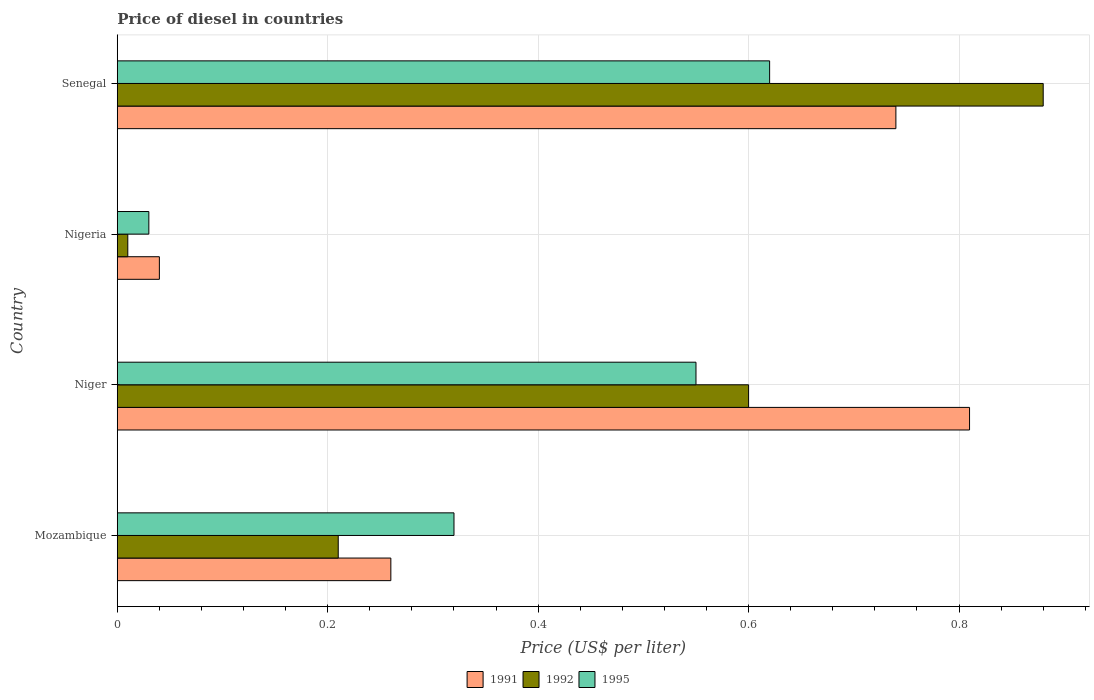What is the label of the 4th group of bars from the top?
Give a very brief answer. Mozambique. What is the price of diesel in 1991 in Nigeria?
Your answer should be compact. 0.04. Across all countries, what is the maximum price of diesel in 1991?
Offer a terse response. 0.81. Across all countries, what is the minimum price of diesel in 1991?
Ensure brevity in your answer.  0.04. In which country was the price of diesel in 1995 maximum?
Your answer should be very brief. Senegal. In which country was the price of diesel in 1995 minimum?
Ensure brevity in your answer.  Nigeria. What is the total price of diesel in 1991 in the graph?
Offer a terse response. 1.85. What is the difference between the price of diesel in 1991 in Niger and that in Senegal?
Ensure brevity in your answer.  0.07. What is the difference between the price of diesel in 1992 in Niger and the price of diesel in 1995 in Nigeria?
Offer a terse response. 0.57. What is the average price of diesel in 1991 per country?
Provide a short and direct response. 0.46. What is the difference between the price of diesel in 1991 and price of diesel in 1992 in Niger?
Give a very brief answer. 0.21. What is the ratio of the price of diesel in 1992 in Mozambique to that in Nigeria?
Make the answer very short. 21. Is the price of diesel in 1995 in Niger less than that in Nigeria?
Ensure brevity in your answer.  No. What is the difference between the highest and the second highest price of diesel in 1992?
Offer a terse response. 0.28. What is the difference between the highest and the lowest price of diesel in 1992?
Keep it short and to the point. 0.87. In how many countries, is the price of diesel in 1991 greater than the average price of diesel in 1991 taken over all countries?
Offer a terse response. 2. Is the sum of the price of diesel in 1992 in Mozambique and Senegal greater than the maximum price of diesel in 1991 across all countries?
Ensure brevity in your answer.  Yes. What does the 3rd bar from the bottom in Mozambique represents?
Give a very brief answer. 1995. Is it the case that in every country, the sum of the price of diesel in 1992 and price of diesel in 1991 is greater than the price of diesel in 1995?
Provide a short and direct response. Yes. How many bars are there?
Make the answer very short. 12. Are all the bars in the graph horizontal?
Keep it short and to the point. Yes. How many countries are there in the graph?
Give a very brief answer. 4. What is the difference between two consecutive major ticks on the X-axis?
Your answer should be compact. 0.2. Are the values on the major ticks of X-axis written in scientific E-notation?
Offer a very short reply. No. Does the graph contain grids?
Your answer should be very brief. Yes. How many legend labels are there?
Offer a terse response. 3. What is the title of the graph?
Offer a very short reply. Price of diesel in countries. Does "2006" appear as one of the legend labels in the graph?
Provide a short and direct response. No. What is the label or title of the X-axis?
Offer a terse response. Price (US$ per liter). What is the Price (US$ per liter) in 1991 in Mozambique?
Ensure brevity in your answer.  0.26. What is the Price (US$ per liter) of 1992 in Mozambique?
Give a very brief answer. 0.21. What is the Price (US$ per liter) in 1995 in Mozambique?
Ensure brevity in your answer.  0.32. What is the Price (US$ per liter) of 1991 in Niger?
Make the answer very short. 0.81. What is the Price (US$ per liter) of 1992 in Niger?
Your response must be concise. 0.6. What is the Price (US$ per liter) of 1995 in Niger?
Make the answer very short. 0.55. What is the Price (US$ per liter) of 1992 in Nigeria?
Give a very brief answer. 0.01. What is the Price (US$ per liter) in 1995 in Nigeria?
Give a very brief answer. 0.03. What is the Price (US$ per liter) of 1991 in Senegal?
Your response must be concise. 0.74. What is the Price (US$ per liter) in 1995 in Senegal?
Provide a short and direct response. 0.62. Across all countries, what is the maximum Price (US$ per liter) in 1991?
Keep it short and to the point. 0.81. Across all countries, what is the maximum Price (US$ per liter) in 1995?
Provide a succinct answer. 0.62. Across all countries, what is the minimum Price (US$ per liter) in 1991?
Offer a terse response. 0.04. What is the total Price (US$ per liter) in 1991 in the graph?
Ensure brevity in your answer.  1.85. What is the total Price (US$ per liter) of 1992 in the graph?
Provide a short and direct response. 1.7. What is the total Price (US$ per liter) in 1995 in the graph?
Make the answer very short. 1.52. What is the difference between the Price (US$ per liter) in 1991 in Mozambique and that in Niger?
Keep it short and to the point. -0.55. What is the difference between the Price (US$ per liter) in 1992 in Mozambique and that in Niger?
Keep it short and to the point. -0.39. What is the difference between the Price (US$ per liter) of 1995 in Mozambique and that in Niger?
Give a very brief answer. -0.23. What is the difference between the Price (US$ per liter) in 1991 in Mozambique and that in Nigeria?
Your answer should be very brief. 0.22. What is the difference between the Price (US$ per liter) of 1995 in Mozambique and that in Nigeria?
Your answer should be compact. 0.29. What is the difference between the Price (US$ per liter) in 1991 in Mozambique and that in Senegal?
Keep it short and to the point. -0.48. What is the difference between the Price (US$ per liter) of 1992 in Mozambique and that in Senegal?
Offer a terse response. -0.67. What is the difference between the Price (US$ per liter) in 1995 in Mozambique and that in Senegal?
Your answer should be very brief. -0.3. What is the difference between the Price (US$ per liter) in 1991 in Niger and that in Nigeria?
Keep it short and to the point. 0.77. What is the difference between the Price (US$ per liter) in 1992 in Niger and that in Nigeria?
Give a very brief answer. 0.59. What is the difference between the Price (US$ per liter) in 1995 in Niger and that in Nigeria?
Give a very brief answer. 0.52. What is the difference between the Price (US$ per liter) in 1991 in Niger and that in Senegal?
Give a very brief answer. 0.07. What is the difference between the Price (US$ per liter) of 1992 in Niger and that in Senegal?
Provide a succinct answer. -0.28. What is the difference between the Price (US$ per liter) in 1995 in Niger and that in Senegal?
Make the answer very short. -0.07. What is the difference between the Price (US$ per liter) of 1991 in Nigeria and that in Senegal?
Ensure brevity in your answer.  -0.7. What is the difference between the Price (US$ per liter) in 1992 in Nigeria and that in Senegal?
Your answer should be compact. -0.87. What is the difference between the Price (US$ per liter) in 1995 in Nigeria and that in Senegal?
Offer a terse response. -0.59. What is the difference between the Price (US$ per liter) in 1991 in Mozambique and the Price (US$ per liter) in 1992 in Niger?
Offer a very short reply. -0.34. What is the difference between the Price (US$ per liter) in 1991 in Mozambique and the Price (US$ per liter) in 1995 in Niger?
Keep it short and to the point. -0.29. What is the difference between the Price (US$ per liter) of 1992 in Mozambique and the Price (US$ per liter) of 1995 in Niger?
Offer a terse response. -0.34. What is the difference between the Price (US$ per liter) of 1991 in Mozambique and the Price (US$ per liter) of 1992 in Nigeria?
Make the answer very short. 0.25. What is the difference between the Price (US$ per liter) of 1991 in Mozambique and the Price (US$ per liter) of 1995 in Nigeria?
Ensure brevity in your answer.  0.23. What is the difference between the Price (US$ per liter) in 1992 in Mozambique and the Price (US$ per liter) in 1995 in Nigeria?
Provide a succinct answer. 0.18. What is the difference between the Price (US$ per liter) in 1991 in Mozambique and the Price (US$ per liter) in 1992 in Senegal?
Offer a very short reply. -0.62. What is the difference between the Price (US$ per liter) of 1991 in Mozambique and the Price (US$ per liter) of 1995 in Senegal?
Ensure brevity in your answer.  -0.36. What is the difference between the Price (US$ per liter) of 1992 in Mozambique and the Price (US$ per liter) of 1995 in Senegal?
Your response must be concise. -0.41. What is the difference between the Price (US$ per liter) of 1991 in Niger and the Price (US$ per liter) of 1992 in Nigeria?
Offer a terse response. 0.8. What is the difference between the Price (US$ per liter) in 1991 in Niger and the Price (US$ per liter) in 1995 in Nigeria?
Provide a short and direct response. 0.78. What is the difference between the Price (US$ per liter) of 1992 in Niger and the Price (US$ per liter) of 1995 in Nigeria?
Ensure brevity in your answer.  0.57. What is the difference between the Price (US$ per liter) in 1991 in Niger and the Price (US$ per liter) in 1992 in Senegal?
Offer a very short reply. -0.07. What is the difference between the Price (US$ per liter) of 1991 in Niger and the Price (US$ per liter) of 1995 in Senegal?
Your answer should be compact. 0.19. What is the difference between the Price (US$ per liter) in 1992 in Niger and the Price (US$ per liter) in 1995 in Senegal?
Keep it short and to the point. -0.02. What is the difference between the Price (US$ per liter) of 1991 in Nigeria and the Price (US$ per liter) of 1992 in Senegal?
Your response must be concise. -0.84. What is the difference between the Price (US$ per liter) in 1991 in Nigeria and the Price (US$ per liter) in 1995 in Senegal?
Provide a short and direct response. -0.58. What is the difference between the Price (US$ per liter) of 1992 in Nigeria and the Price (US$ per liter) of 1995 in Senegal?
Keep it short and to the point. -0.61. What is the average Price (US$ per liter) of 1991 per country?
Provide a succinct answer. 0.46. What is the average Price (US$ per liter) in 1992 per country?
Ensure brevity in your answer.  0.42. What is the average Price (US$ per liter) in 1995 per country?
Your answer should be very brief. 0.38. What is the difference between the Price (US$ per liter) in 1991 and Price (US$ per liter) in 1992 in Mozambique?
Keep it short and to the point. 0.05. What is the difference between the Price (US$ per liter) in 1991 and Price (US$ per liter) in 1995 in Mozambique?
Your answer should be very brief. -0.06. What is the difference between the Price (US$ per liter) in 1992 and Price (US$ per liter) in 1995 in Mozambique?
Provide a succinct answer. -0.11. What is the difference between the Price (US$ per liter) of 1991 and Price (US$ per liter) of 1992 in Niger?
Provide a short and direct response. 0.21. What is the difference between the Price (US$ per liter) of 1991 and Price (US$ per liter) of 1995 in Niger?
Your answer should be very brief. 0.26. What is the difference between the Price (US$ per liter) of 1992 and Price (US$ per liter) of 1995 in Nigeria?
Offer a very short reply. -0.02. What is the difference between the Price (US$ per liter) in 1991 and Price (US$ per liter) in 1992 in Senegal?
Your response must be concise. -0.14. What is the difference between the Price (US$ per liter) in 1991 and Price (US$ per liter) in 1995 in Senegal?
Give a very brief answer. 0.12. What is the difference between the Price (US$ per liter) in 1992 and Price (US$ per liter) in 1995 in Senegal?
Make the answer very short. 0.26. What is the ratio of the Price (US$ per liter) of 1991 in Mozambique to that in Niger?
Your response must be concise. 0.32. What is the ratio of the Price (US$ per liter) of 1995 in Mozambique to that in Niger?
Provide a succinct answer. 0.58. What is the ratio of the Price (US$ per liter) of 1991 in Mozambique to that in Nigeria?
Provide a short and direct response. 6.5. What is the ratio of the Price (US$ per liter) of 1995 in Mozambique to that in Nigeria?
Offer a terse response. 10.67. What is the ratio of the Price (US$ per liter) in 1991 in Mozambique to that in Senegal?
Your response must be concise. 0.35. What is the ratio of the Price (US$ per liter) in 1992 in Mozambique to that in Senegal?
Your response must be concise. 0.24. What is the ratio of the Price (US$ per liter) in 1995 in Mozambique to that in Senegal?
Your answer should be compact. 0.52. What is the ratio of the Price (US$ per liter) of 1991 in Niger to that in Nigeria?
Ensure brevity in your answer.  20.25. What is the ratio of the Price (US$ per liter) of 1992 in Niger to that in Nigeria?
Keep it short and to the point. 60. What is the ratio of the Price (US$ per liter) of 1995 in Niger to that in Nigeria?
Provide a succinct answer. 18.33. What is the ratio of the Price (US$ per liter) of 1991 in Niger to that in Senegal?
Make the answer very short. 1.09. What is the ratio of the Price (US$ per liter) in 1992 in Niger to that in Senegal?
Give a very brief answer. 0.68. What is the ratio of the Price (US$ per liter) of 1995 in Niger to that in Senegal?
Give a very brief answer. 0.89. What is the ratio of the Price (US$ per liter) in 1991 in Nigeria to that in Senegal?
Offer a terse response. 0.05. What is the ratio of the Price (US$ per liter) in 1992 in Nigeria to that in Senegal?
Provide a short and direct response. 0.01. What is the ratio of the Price (US$ per liter) of 1995 in Nigeria to that in Senegal?
Your answer should be compact. 0.05. What is the difference between the highest and the second highest Price (US$ per liter) in 1991?
Offer a very short reply. 0.07. What is the difference between the highest and the second highest Price (US$ per liter) of 1992?
Provide a succinct answer. 0.28. What is the difference between the highest and the second highest Price (US$ per liter) in 1995?
Your response must be concise. 0.07. What is the difference between the highest and the lowest Price (US$ per liter) in 1991?
Ensure brevity in your answer.  0.77. What is the difference between the highest and the lowest Price (US$ per liter) of 1992?
Offer a terse response. 0.87. What is the difference between the highest and the lowest Price (US$ per liter) in 1995?
Provide a succinct answer. 0.59. 